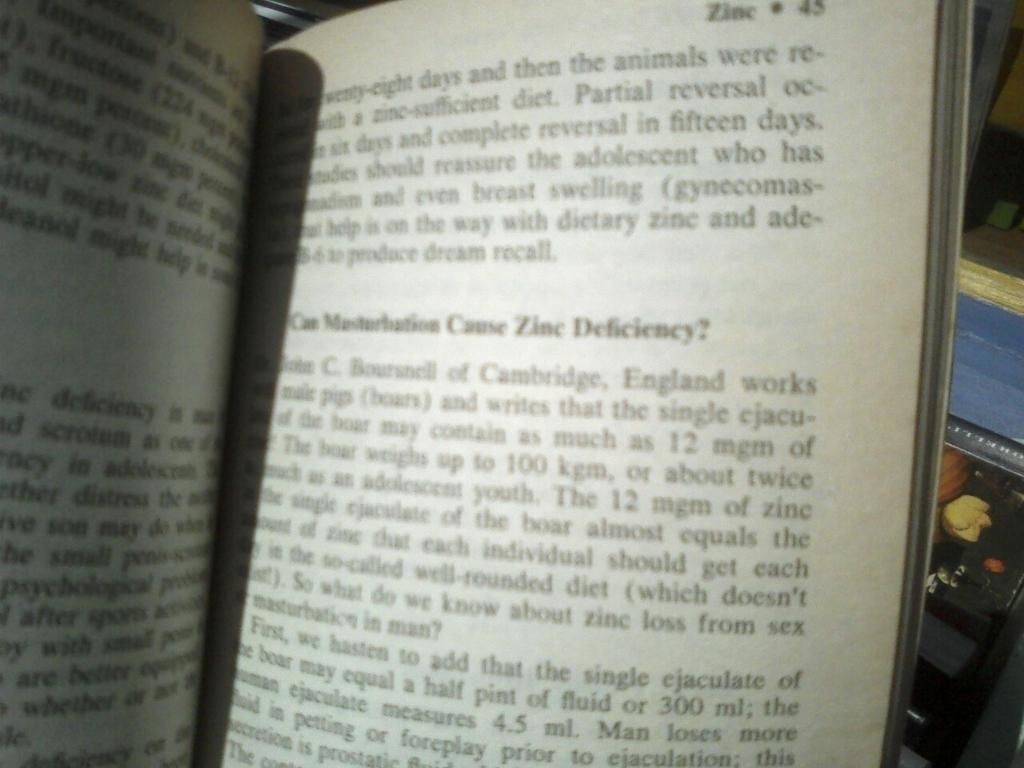What type of deficiency does this section of the book discuss?
Provide a succinct answer. Zinc. What page is the book on?
Offer a terse response. 45. 